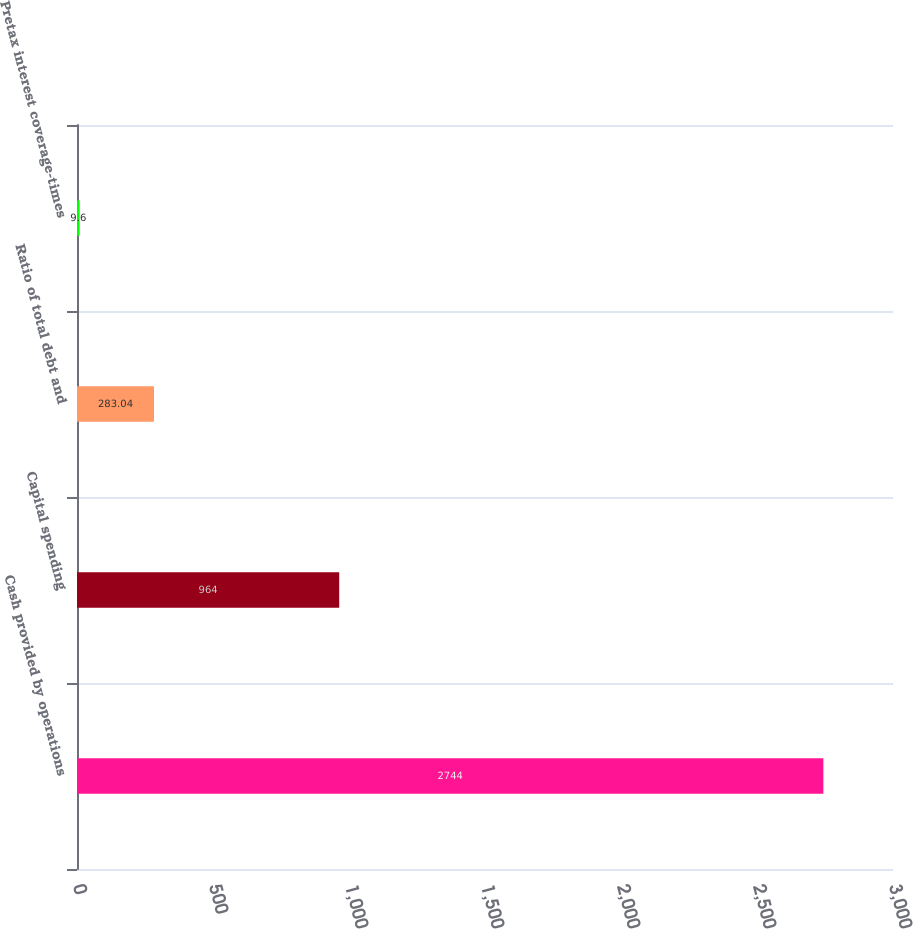Convert chart. <chart><loc_0><loc_0><loc_500><loc_500><bar_chart><fcel>Cash provided by operations<fcel>Capital spending<fcel>Ratio of total debt and<fcel>Pretax interest coverage-times<nl><fcel>2744<fcel>964<fcel>283.04<fcel>9.6<nl></chart> 